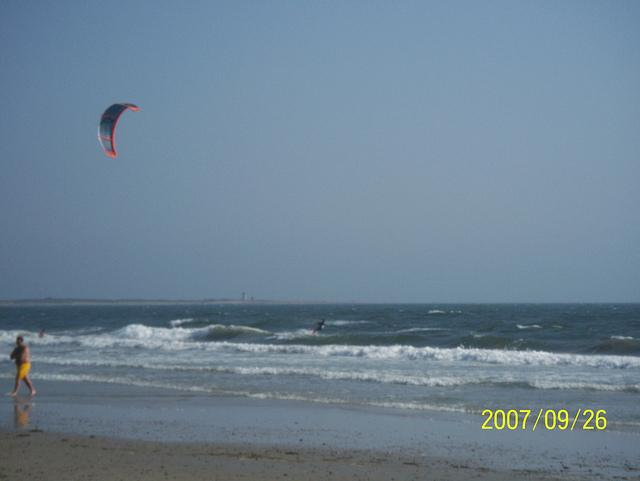How much older is this man now?

Choices:
A) 10 years
B) 22 years
C) 14 years
D) 30 years 14 years 